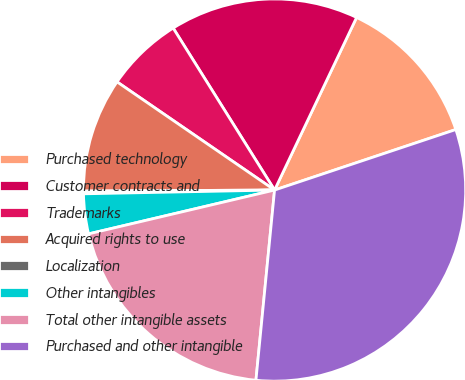Convert chart to OTSL. <chart><loc_0><loc_0><loc_500><loc_500><pie_chart><fcel>Purchased technology<fcel>Customer contracts and<fcel>Trademarks<fcel>Acquired rights to use<fcel>Localization<fcel>Other intangibles<fcel>Total other intangible assets<fcel>Purchased and other intangible<nl><fcel>12.81%<fcel>15.96%<fcel>6.52%<fcel>9.66%<fcel>0.23%<fcel>3.37%<fcel>19.76%<fcel>31.68%<nl></chart> 